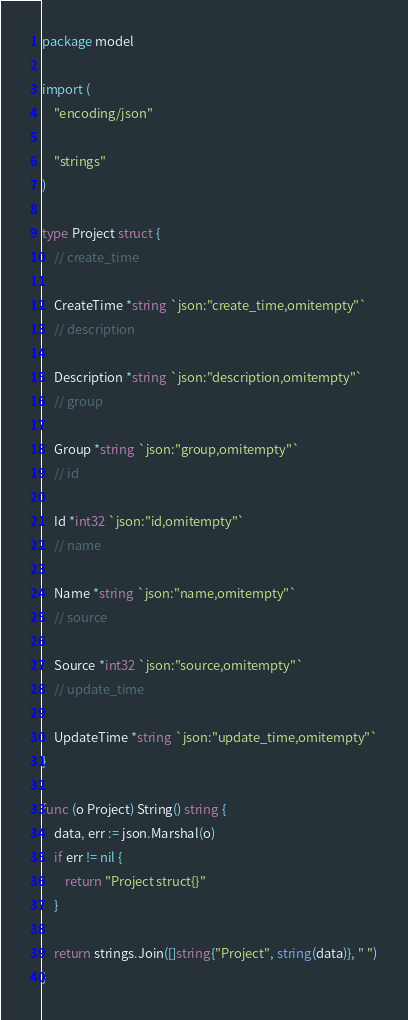Convert code to text. <code><loc_0><loc_0><loc_500><loc_500><_Go_>package model

import (
	"encoding/json"

	"strings"
)

type Project struct {
	// create_time

	CreateTime *string `json:"create_time,omitempty"`
	// description

	Description *string `json:"description,omitempty"`
	// group

	Group *string `json:"group,omitempty"`
	// id

	Id *int32 `json:"id,omitempty"`
	// name

	Name *string `json:"name,omitempty"`
	// source

	Source *int32 `json:"source,omitempty"`
	// update_time

	UpdateTime *string `json:"update_time,omitempty"`
}

func (o Project) String() string {
	data, err := json.Marshal(o)
	if err != nil {
		return "Project struct{}"
	}

	return strings.Join([]string{"Project", string(data)}, " ")
}
</code> 